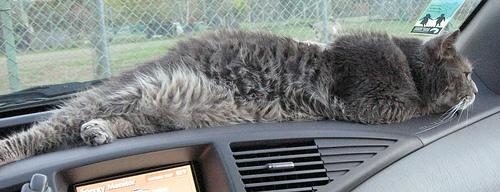Is the cat laying on a car?
Short answer required. Yes. What two car parts are below the cat?
Keep it brief. Radio, air conditioner. Is the cat inside the car?
Keep it brief. Yes. 